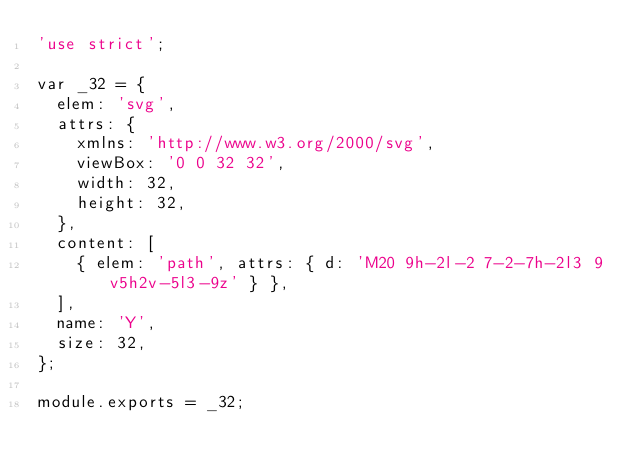<code> <loc_0><loc_0><loc_500><loc_500><_JavaScript_>'use strict';

var _32 = {
  elem: 'svg',
  attrs: {
    xmlns: 'http://www.w3.org/2000/svg',
    viewBox: '0 0 32 32',
    width: 32,
    height: 32,
  },
  content: [
    { elem: 'path', attrs: { d: 'M20 9h-2l-2 7-2-7h-2l3 9v5h2v-5l3-9z' } },
  ],
  name: 'Y',
  size: 32,
};

module.exports = _32;
</code> 